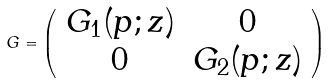<formula> <loc_0><loc_0><loc_500><loc_500>G = \left ( \begin{array} { c c } G _ { 1 } ( p ; z ) & 0 \\ 0 & G _ { 2 } ( p ; z ) \end{array} \right )</formula> 